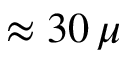<formula> <loc_0><loc_0><loc_500><loc_500>\approx 3 0 \, \mu</formula> 